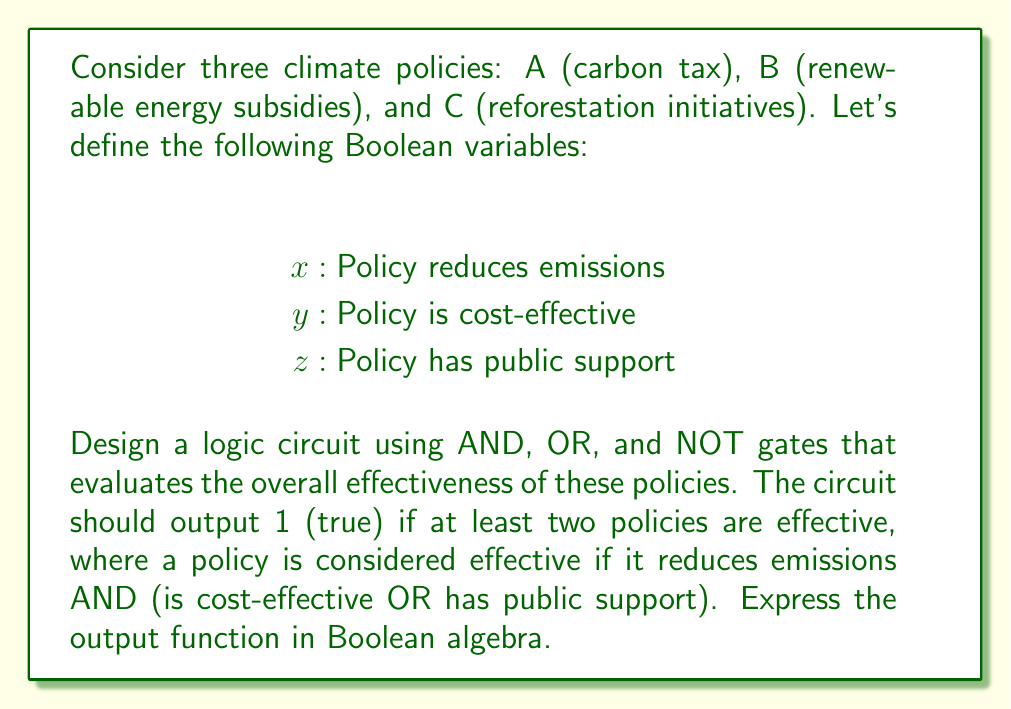What is the answer to this math problem? Let's approach this step-by-step:

1) First, we need to define what makes a policy effective. Based on the question, a policy is effective if:
   $$(x \land (y \lor z))$$

2) We need to evaluate this for each policy A, B, and C. Let's denote the effectiveness of each policy as $E_A$, $E_B$, and $E_C$:

   $E_A = x_A \land (y_A \lor z_A)$
   $E_B = x_B \land (y_B \lor z_B)$
   $E_C = x_C \land (y_C \lor z_C)$

3) The overall output should be true if at least two of these are true. We can express this as:

   $$(E_A \land E_B) \lor (E_A \land E_C) \lor (E_B \land E_C)$$

4) Substituting the expressions for $E_A$, $E_B$, and $E_C$:

   $$\begin{aligned}
   &([x_A \land (y_A \lor z_A)] \land [x_B \land (y_B \lor z_B)]) \lor \\
   &([x_A \land (y_A \lor z_A)] \land [x_C \land (y_C \lor z_C)]) \lor \\
   &([x_B \land (y_B \lor z_B)] \land [x_C \land (y_C \lor z_C)])
   \end{aligned}$$

5) This Boolean expression represents the logic circuit that evaluates the overall effectiveness of the climate policies.

[asy]
import geometry;

// Define points for the gates
pair A1=(0,80), A2=(0,60), A3=(0,40);
pair O1=(40,70), O2=(40,50);
pair A4=(80,60);
pair B1=(0,0), B2=(0,-20), B3=(0,-40);
pair O3=(40,-10), O4=(40,-30);
pair A5=(80,-20);
pair C1=(0,-80), C2=(0,-100), C3=(0,-120);
pair O5=(40,-90), O6=(40,-110);
pair A6=(80,-100);
pair O7=(120,20), O8=(120,-60);
pair A7=(160,-20);

// Draw AND gates
draw(A1--A2--A3--A1);
draw(A4--A4+20*dir(0), arrow=Arrow(TeXHead));
draw(B1--B2--B3--B1);
draw(A5--A5+20*dir(0), arrow=Arrow(TeXHead));
draw(C1--C2--C3--C1);
draw(A6--A6+20*dir(0), arrow=Arrow(TeXHead));
draw(A7--A7+20*dir(0), arrow=Arrow(TeXHead));

// Draw OR gates
draw(O1--O2--O1);
draw(O3--O4--O3);
draw(O5--O6--O5);
draw(O7--O8--O7);

// Connect gates
draw(A1--O1);
draw(A2--O2);
draw(O1--A4);
draw(B1--O3);
draw(B2--O4);
draw(O3--A5);
draw(C1--O5);
draw(C2--O6);
draw(O5--A6);
draw(A4--O7);
draw(A5--A5+(O7-A5)/2--O7);
draw(A6--A6+(O8-A6)/2--O8);
draw(O7--A7);
draw(O8--A7);

// Label inputs
label("$x_A$", A1, W);
label("$y_A$", A2, W);
label("$z_A$", A3, W);
label("$x_B$", B1, W);
label("$y_B$", B2, W);
label("$z_B$", B3, W);
label("$x_C$", C1, W);
label("$y_C$", C2, W);
label("$z_C$", C3, W);

// Label output
label("Output", A7+20*dir(0), E);
[/asy]

This circuit implements the Boolean function we derived, evaluating the effectiveness of the climate policies based on the given criteria.
Answer: The Boolean expression for the overall effectiveness of the climate policies is:

$$\begin{aligned}
&([x_A \land (y_A \lor z_A)] \land [x_B \land (y_B \lor z_B)]) \lor \\
&([x_A \land (y_A \lor z_A)] \land [x_C \land (y_C \lor z_C)]) \lor \\
&([x_B \land (y_B \lor z_B)] \land [x_C \land (y_C \lor z_C)])
\end{aligned}$$

This expression outputs 1 (true) if at least two of the policies are effective, where each policy's effectiveness is determined by whether it reduces emissions AND (is cost-effective OR has public support). 